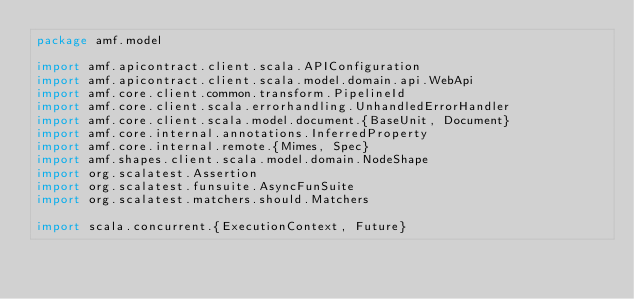Convert code to text. <code><loc_0><loc_0><loc_500><loc_500><_Scala_>package amf.model

import amf.apicontract.client.scala.APIConfiguration
import amf.apicontract.client.scala.model.domain.api.WebApi
import amf.core.client.common.transform.PipelineId
import amf.core.client.scala.errorhandling.UnhandledErrorHandler
import amf.core.client.scala.model.document.{BaseUnit, Document}
import amf.core.internal.annotations.InferredProperty
import amf.core.internal.remote.{Mimes, Spec}
import amf.shapes.client.scala.model.domain.NodeShape
import org.scalatest.Assertion
import org.scalatest.funsuite.AsyncFunSuite
import org.scalatest.matchers.should.Matchers

import scala.concurrent.{ExecutionContext, Future}
</code> 